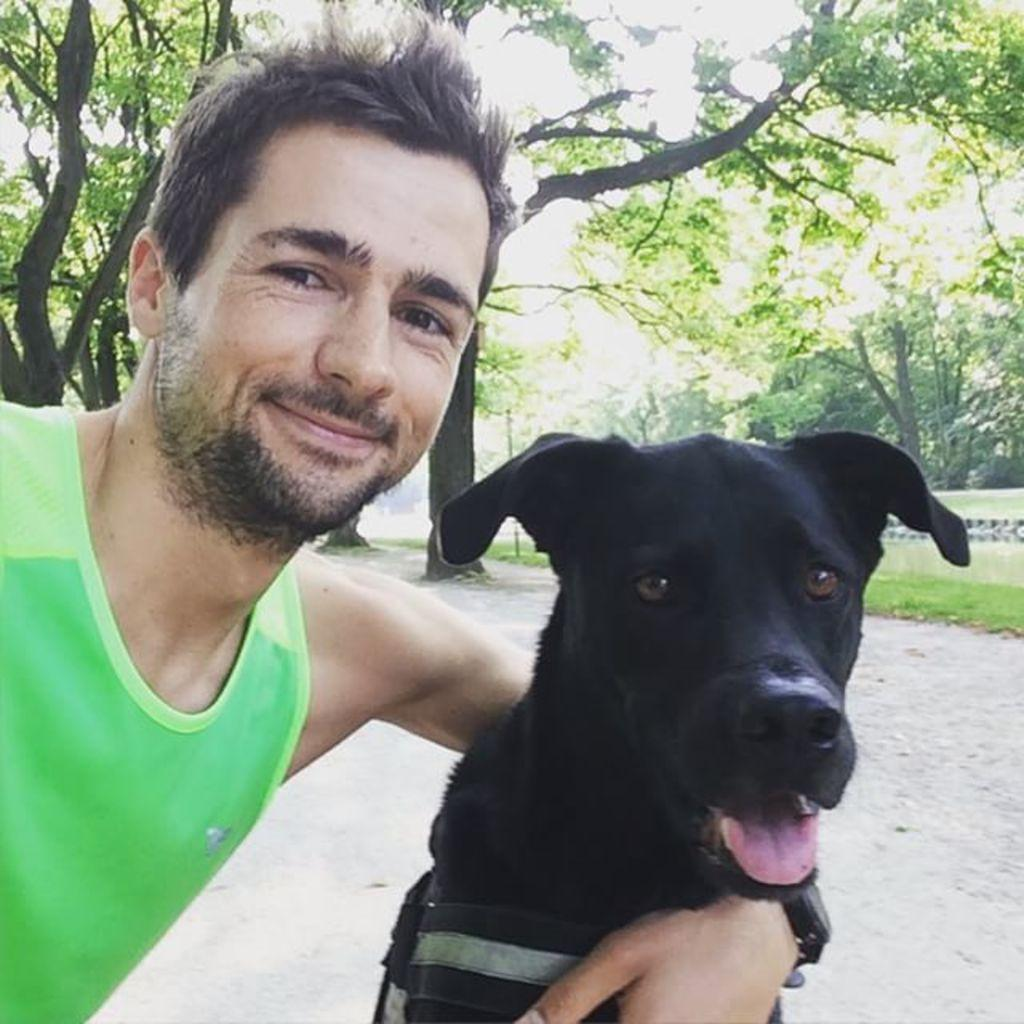What is the person holding in the image? The person is holding a black dog in the image. Can you describe the person's attire? The person is wearing a watch. What can be seen in the background of the image? There are trees, a grass lawn, and a wall in the background of the image. What type of scarecrow can be seen standing in the alley in the image? There is no scarecrow or alley present in the image; it features a person holding a black dog with a grass lawn, trees, and a wall in the background. 